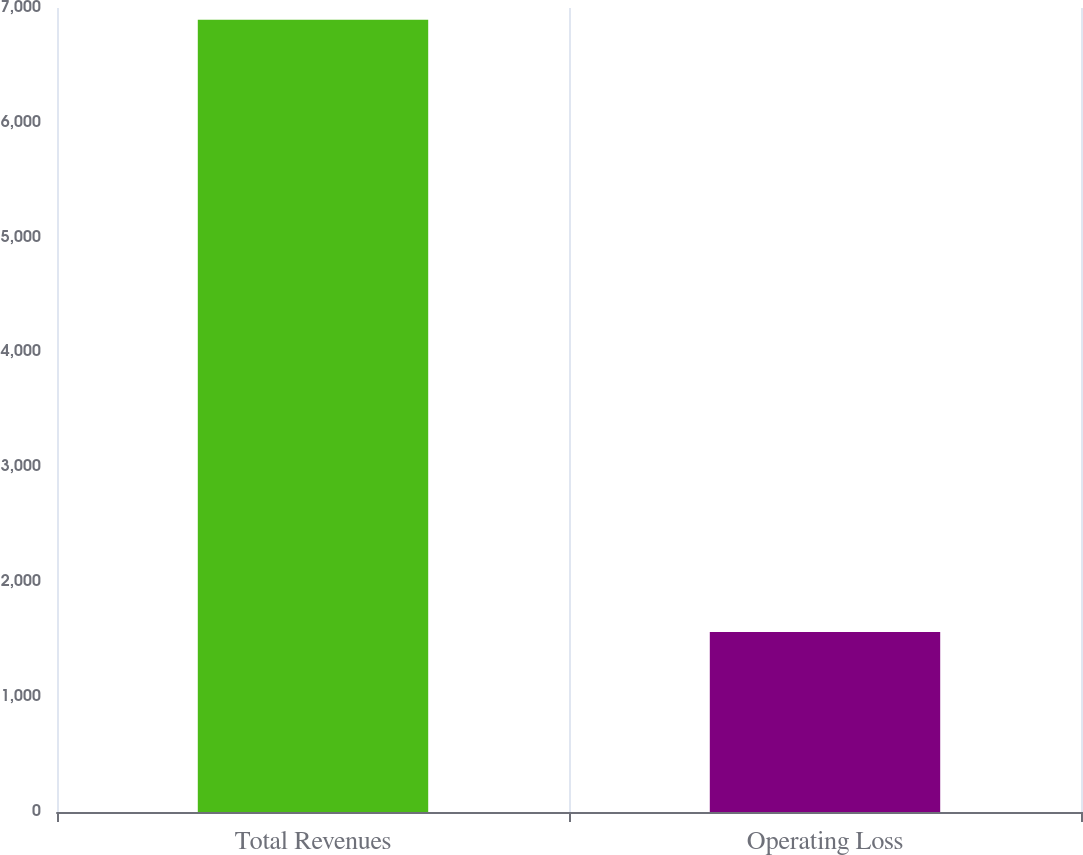Convert chart to OTSL. <chart><loc_0><loc_0><loc_500><loc_500><bar_chart><fcel>Total Revenues<fcel>Operating Loss<nl><fcel>6898<fcel>1568<nl></chart> 